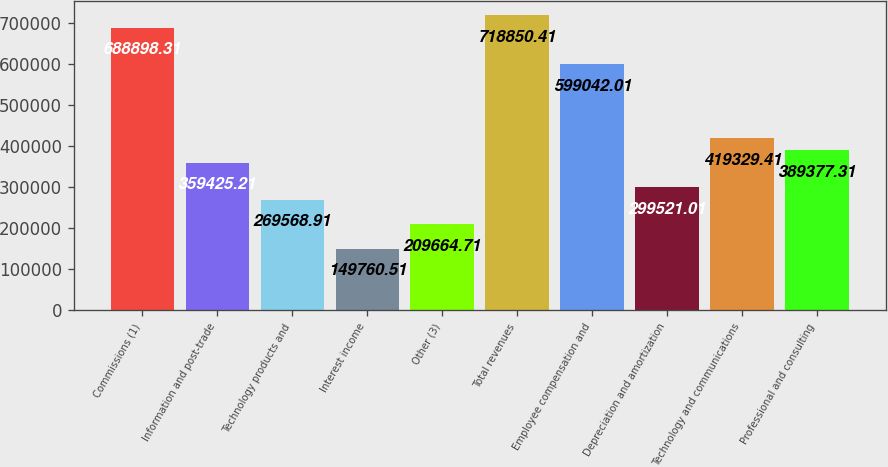Convert chart to OTSL. <chart><loc_0><loc_0><loc_500><loc_500><bar_chart><fcel>Commissions (1)<fcel>Information and post-trade<fcel>Technology products and<fcel>Interest income<fcel>Other (3)<fcel>Total revenues<fcel>Employee compensation and<fcel>Depreciation and amortization<fcel>Technology and communications<fcel>Professional and consulting<nl><fcel>688898<fcel>359425<fcel>269569<fcel>149761<fcel>209665<fcel>718850<fcel>599042<fcel>299521<fcel>419329<fcel>389377<nl></chart> 